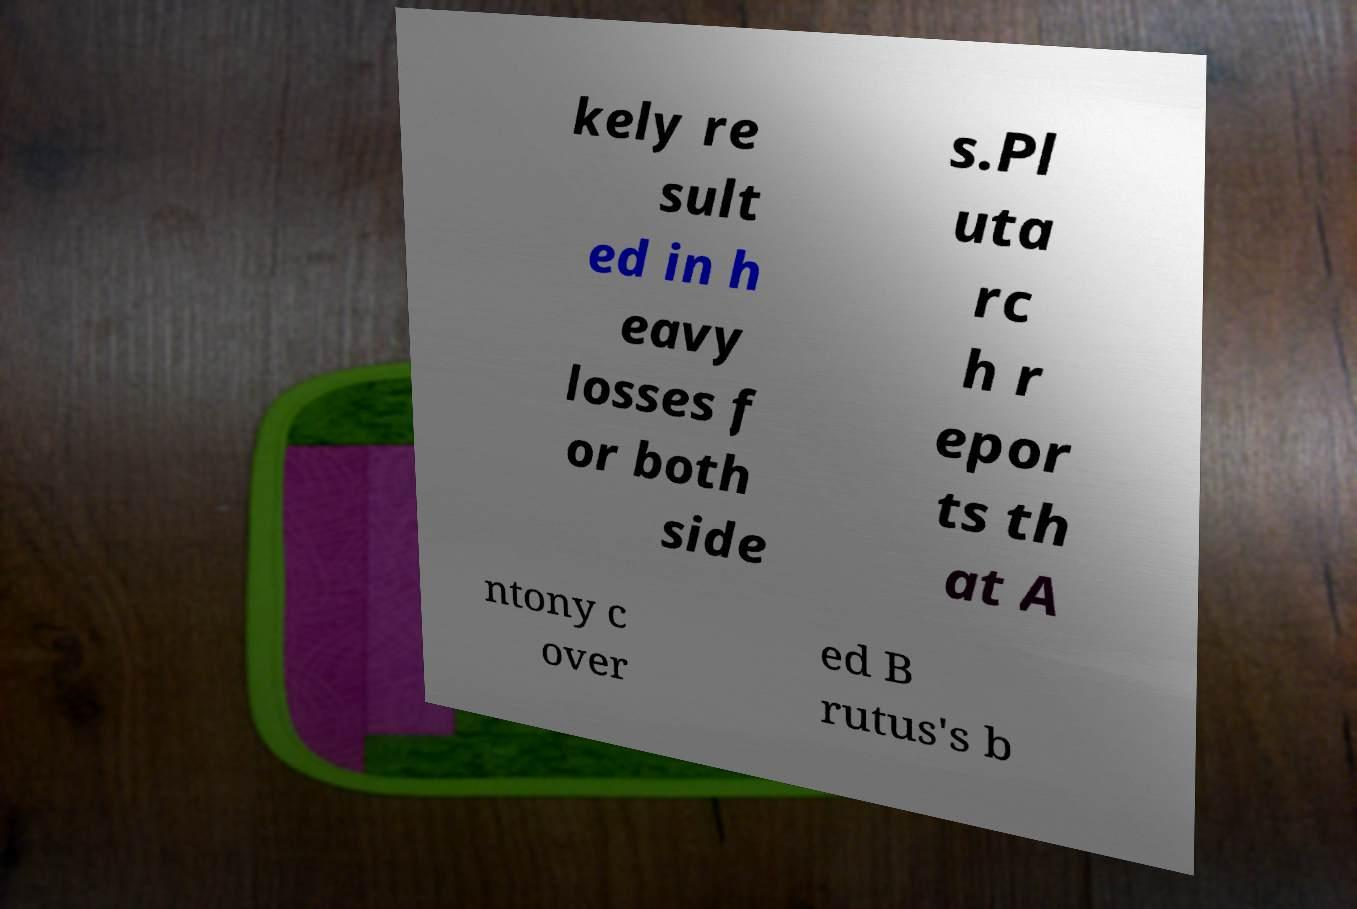Can you read and provide the text displayed in the image?This photo seems to have some interesting text. Can you extract and type it out for me? kely re sult ed in h eavy losses f or both side s.Pl uta rc h r epor ts th at A ntony c over ed B rutus's b 